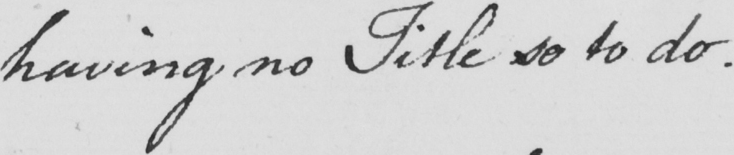Please transcribe the handwritten text in this image. having no Title so to do . 